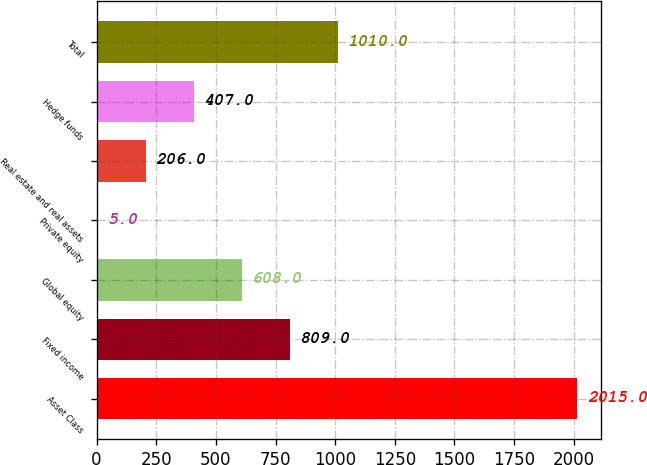Convert chart to OTSL. <chart><loc_0><loc_0><loc_500><loc_500><bar_chart><fcel>Asset Class<fcel>Fixed income<fcel>Global equity<fcel>Private equity<fcel>Real estate and real assets<fcel>Hedge funds<fcel>Total<nl><fcel>2015<fcel>809<fcel>608<fcel>5<fcel>206<fcel>407<fcel>1010<nl></chart> 